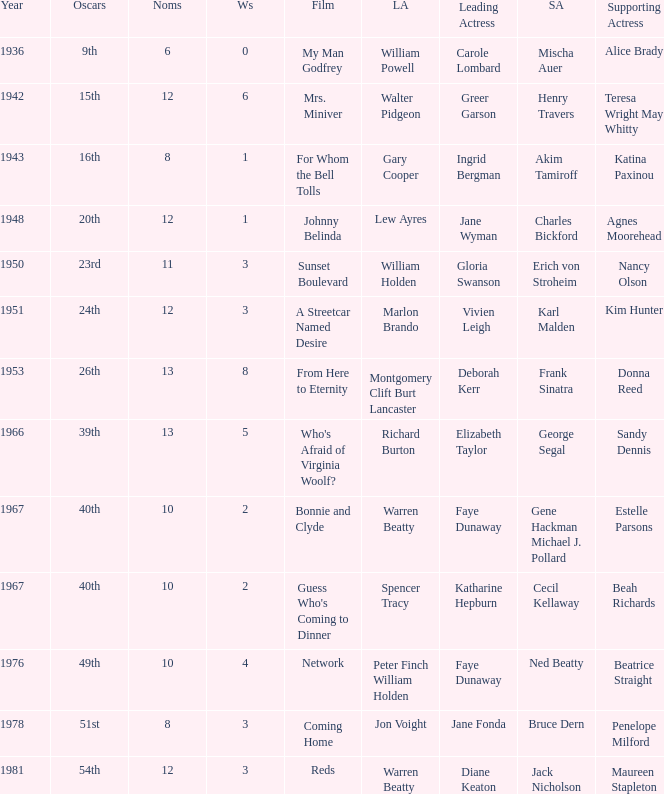Which film had Charles Bickford as supporting actor? Johnny Belinda. 